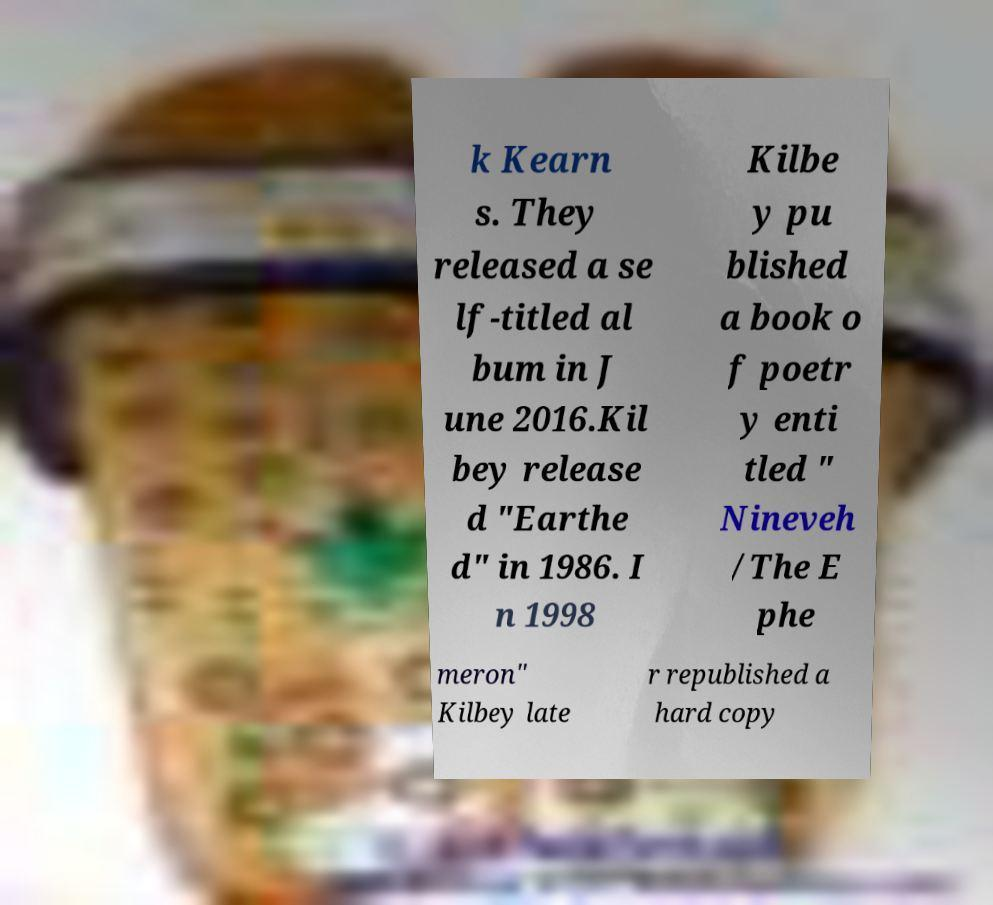Please read and relay the text visible in this image. What does it say? k Kearn s. They released a se lf-titled al bum in J une 2016.Kil bey release d "Earthe d" in 1986. I n 1998 Kilbe y pu blished a book o f poetr y enti tled " Nineveh /The E phe meron" Kilbey late r republished a hard copy 